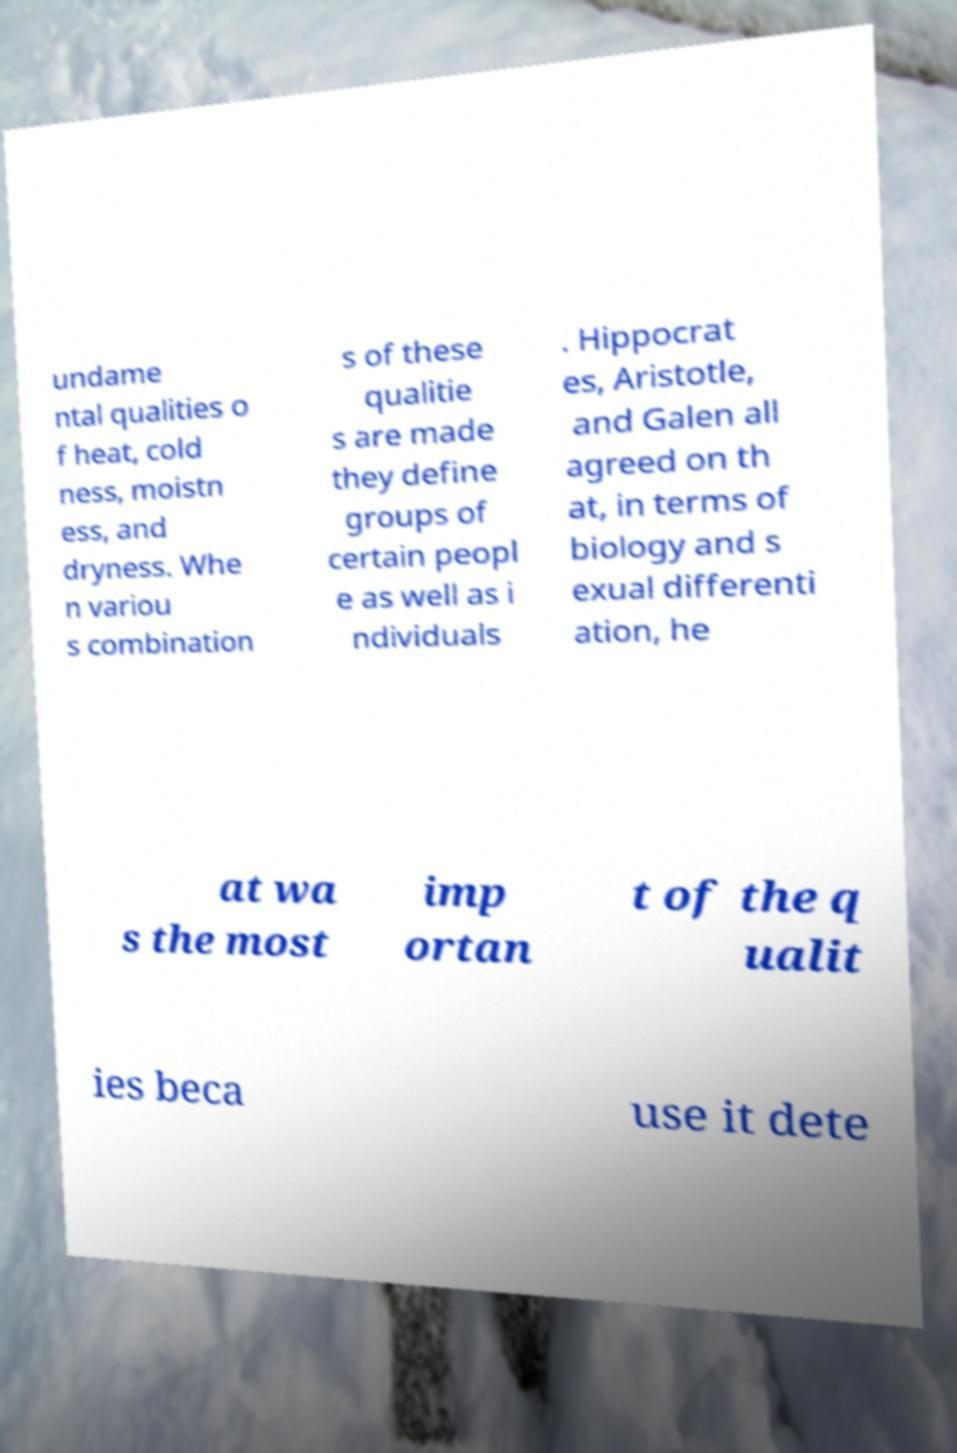Please read and relay the text visible in this image. What does it say? undame ntal qualities o f heat, cold ness, moistn ess, and dryness. Whe n variou s combination s of these qualitie s are made they define groups of certain peopl e as well as i ndividuals . Hippocrat es, Aristotle, and Galen all agreed on th at, in terms of biology and s exual differenti ation, he at wa s the most imp ortan t of the q ualit ies beca use it dete 